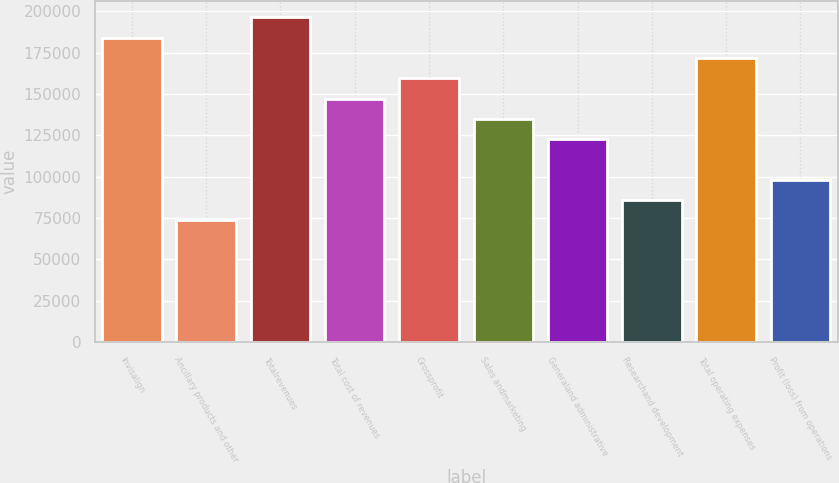<chart> <loc_0><loc_0><loc_500><loc_500><bar_chart><fcel>Invisalign<fcel>Ancillary products and other<fcel>Totalrevenues<fcel>Total cost of revenues<fcel>Grossprofit<fcel>Sales andmarketing<fcel>Generaland administrative<fcel>Researchand development<fcel>Total operating expenses<fcel>Profit (loss) from operations<nl><fcel>184087<fcel>73635.1<fcel>196360<fcel>147270<fcel>159542<fcel>134997<fcel>122725<fcel>85907.6<fcel>171815<fcel>98180.1<nl></chart> 